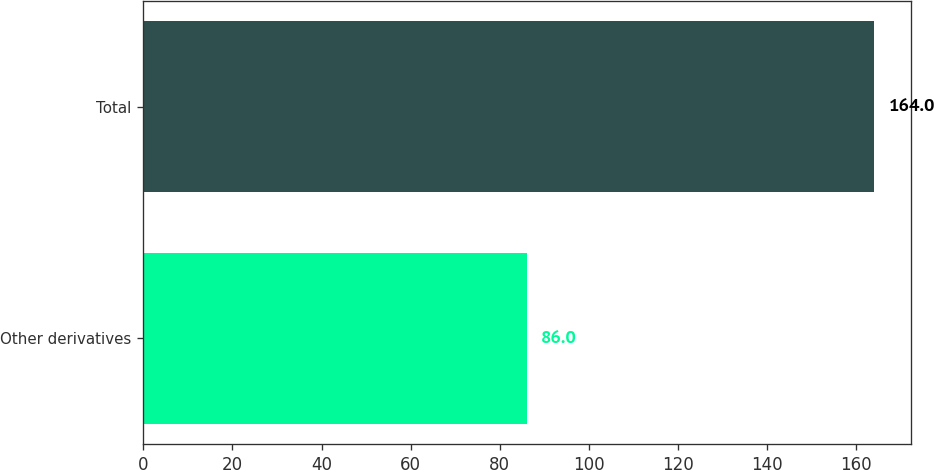Convert chart. <chart><loc_0><loc_0><loc_500><loc_500><bar_chart><fcel>Other derivatives<fcel>Total<nl><fcel>86<fcel>164<nl></chart> 